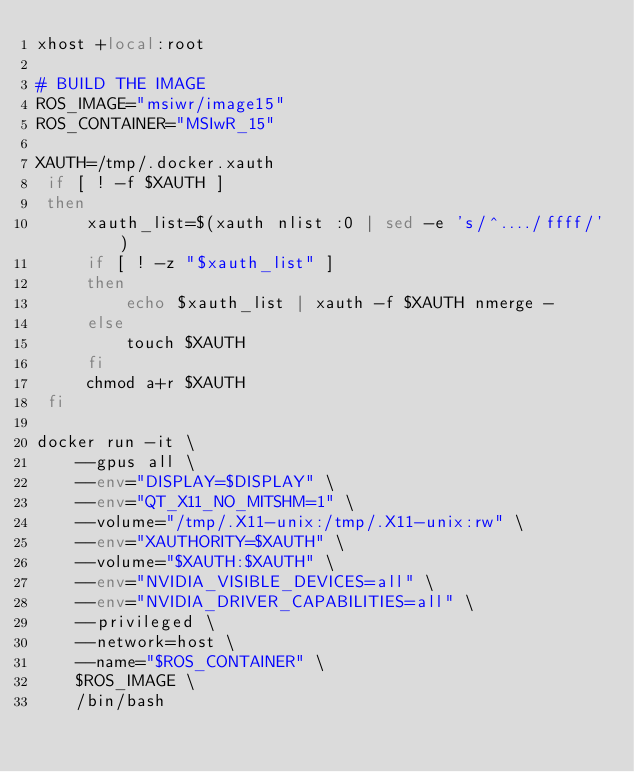Convert code to text. <code><loc_0><loc_0><loc_500><loc_500><_Bash_>xhost +local:root

# BUILD THE IMAGE
ROS_IMAGE="msiwr/image15"
ROS_CONTAINER="MSIwR_15"

XAUTH=/tmp/.docker.xauth
 if [ ! -f $XAUTH ]
 then
     xauth_list=$(xauth nlist :0 | sed -e 's/^..../ffff/')
     if [ ! -z "$xauth_list" ]
     then
         echo $xauth_list | xauth -f $XAUTH nmerge -
     else
         touch $XAUTH
     fi
     chmod a+r $XAUTH
 fi

docker run -it \
    --gpus all \
    --env="DISPLAY=$DISPLAY" \
    --env="QT_X11_NO_MITSHM=1" \
    --volume="/tmp/.X11-unix:/tmp/.X11-unix:rw" \
    --env="XAUTHORITY=$XAUTH" \
    --volume="$XAUTH:$XAUTH" \
    --env="NVIDIA_VISIBLE_DEVICES=all" \
    --env="NVIDIA_DRIVER_CAPABILITIES=all" \
    --privileged \
    --network=host \
    --name="$ROS_CONTAINER" \
    $ROS_IMAGE \
    /bin/bash
</code> 